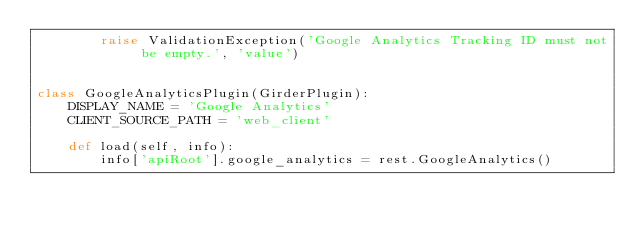Convert code to text. <code><loc_0><loc_0><loc_500><loc_500><_Python_>        raise ValidationException('Google Analytics Tracking ID must not be empty.', 'value')


class GoogleAnalyticsPlugin(GirderPlugin):
    DISPLAY_NAME = 'Google Analytics'
    CLIENT_SOURCE_PATH = 'web_client'

    def load(self, info):
        info['apiRoot'].google_analytics = rest.GoogleAnalytics()
</code> 